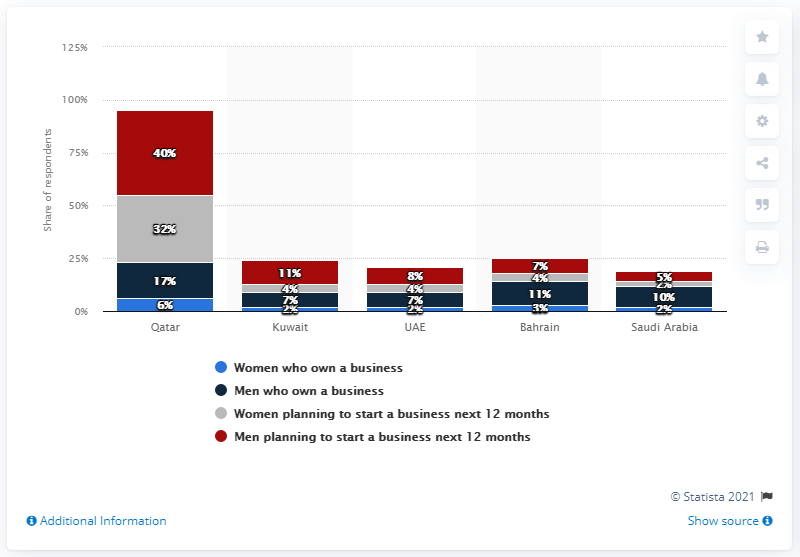Identify some key points in this picture. In Qatar, 32% of female respondents indicated that they plan to start a business within the next 12 months, according to a recent survey. 